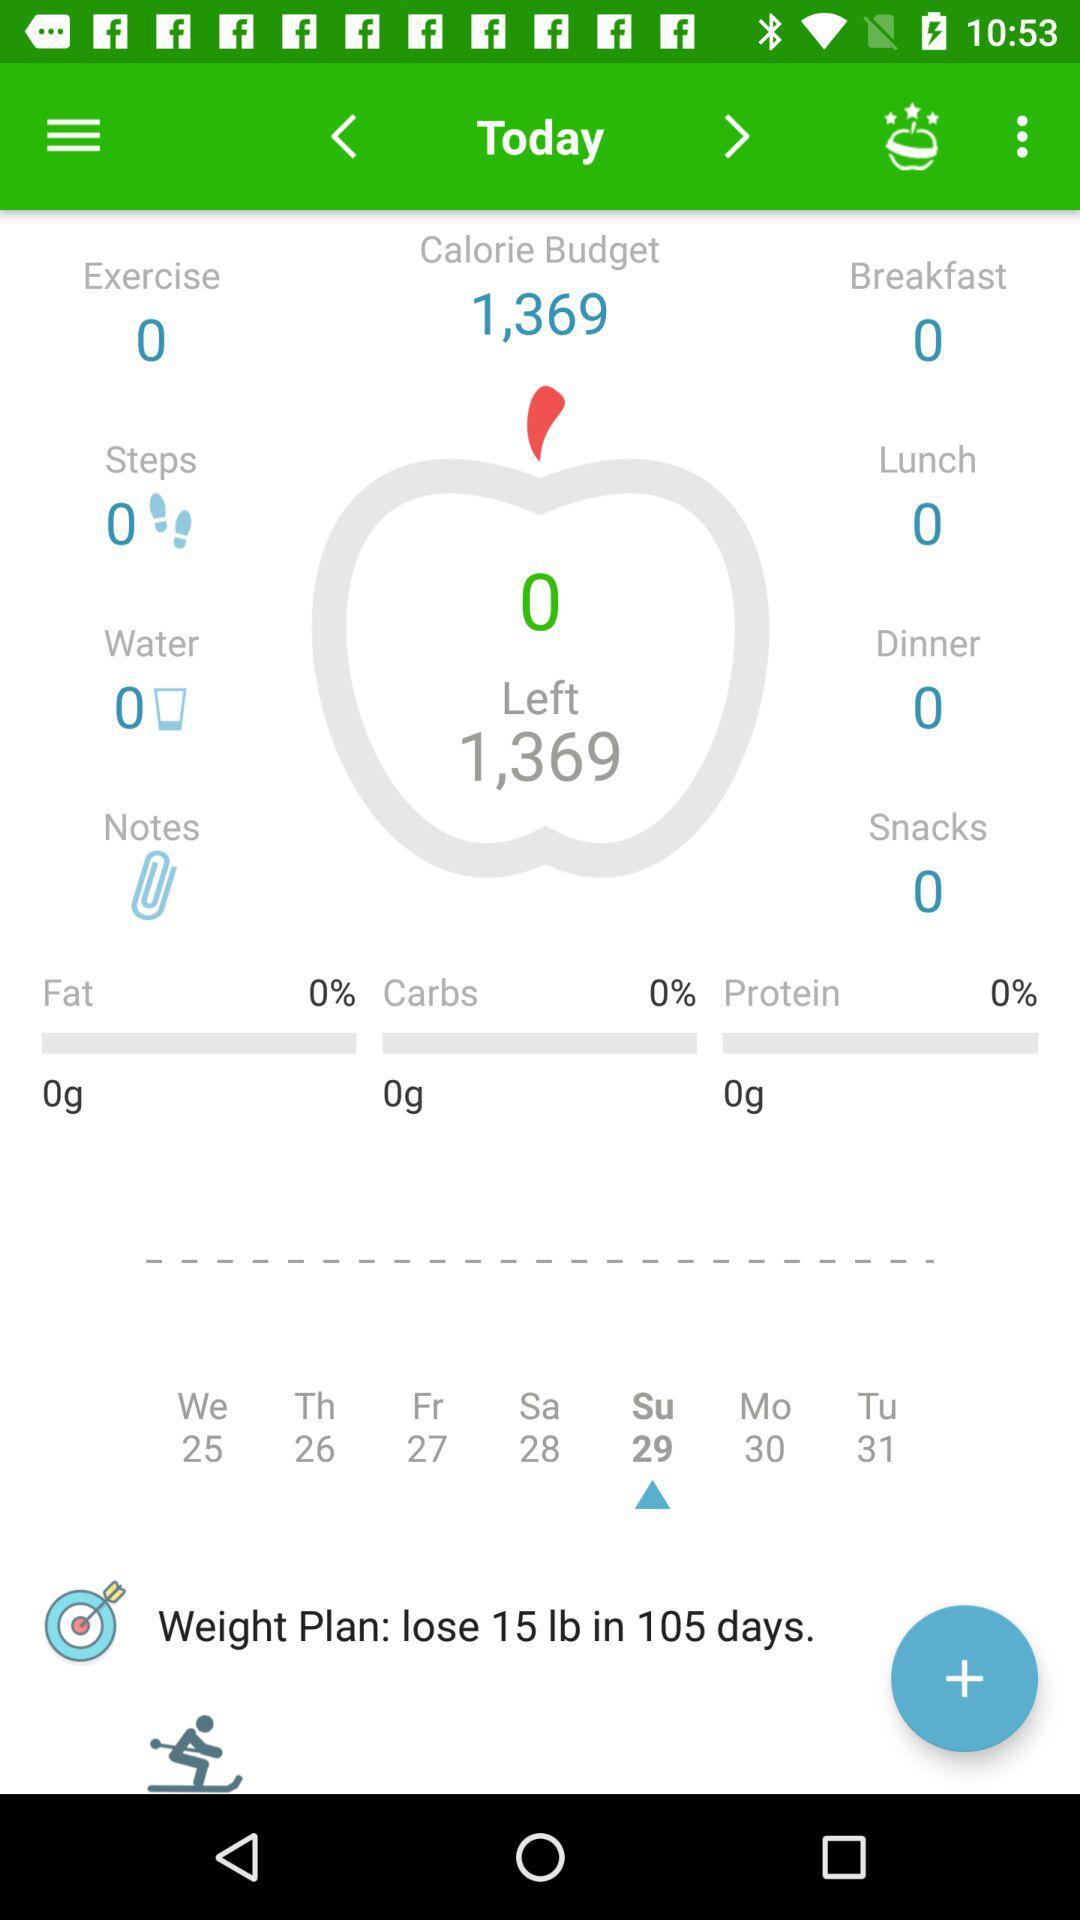How many steps have you taken today?
Answer the question using a single word or phrase. 0 